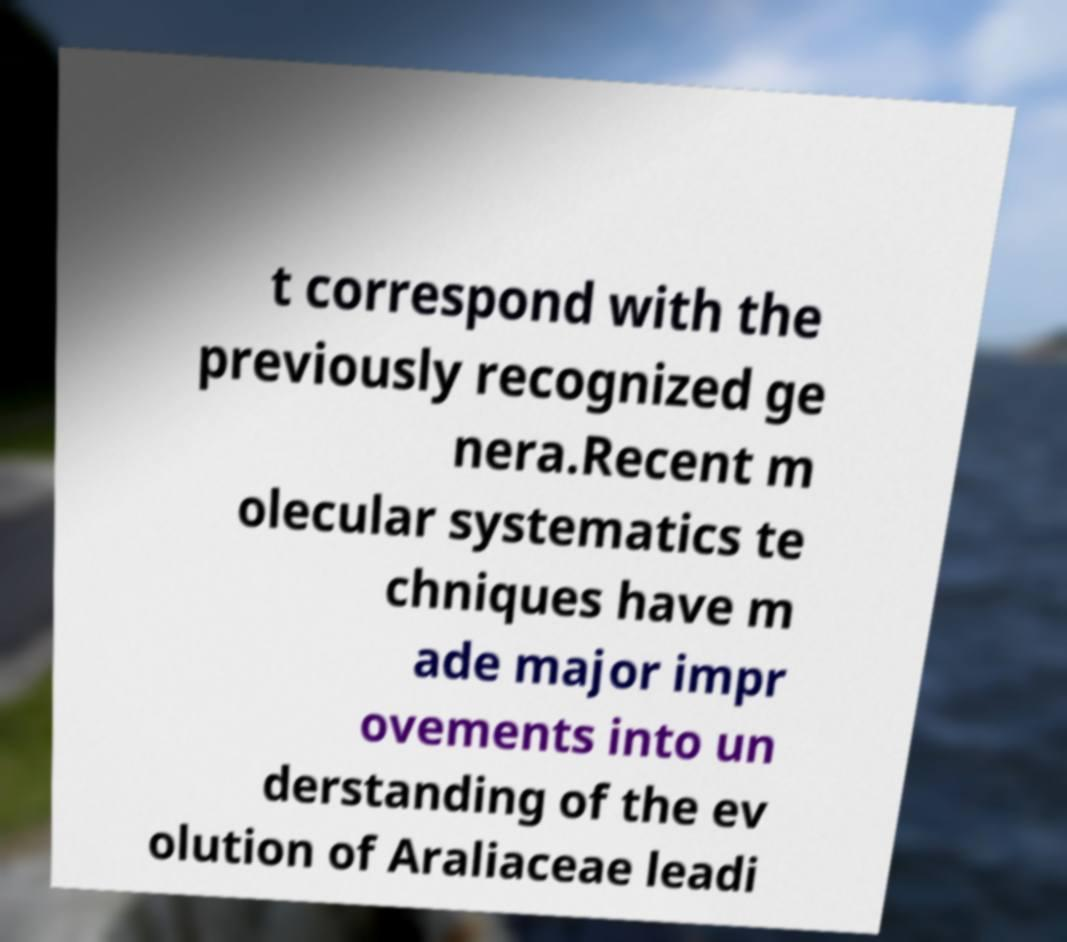Can you accurately transcribe the text from the provided image for me? t correspond with the previously recognized ge nera.Recent m olecular systematics te chniques have m ade major impr ovements into un derstanding of the ev olution of Araliaceae leadi 